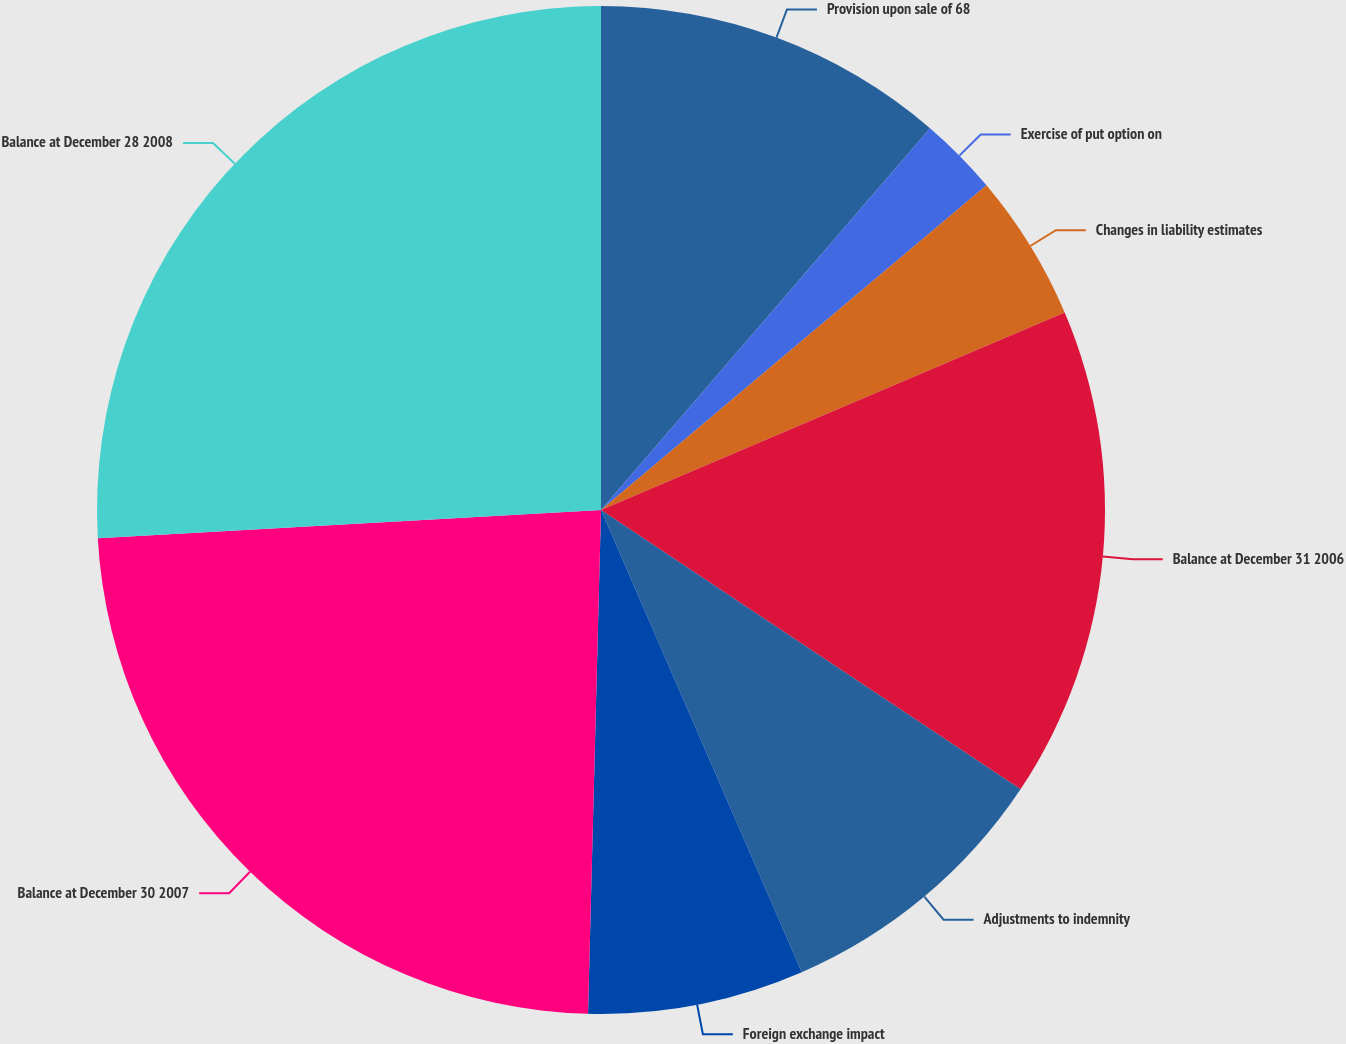Convert chart to OTSL. <chart><loc_0><loc_0><loc_500><loc_500><pie_chart><fcel>Provision upon sale of 68<fcel>Exercise of put option on<fcel>Changes in liability estimates<fcel>Balance at December 31 2006<fcel>Adjustments to indemnity<fcel>Foreign exchange impact<fcel>Balance at December 30 2007<fcel>Balance at December 28 2008<nl><fcel>11.32%<fcel>2.54%<fcel>4.73%<fcel>15.76%<fcel>9.13%<fcel>6.93%<fcel>23.7%<fcel>25.89%<nl></chart> 